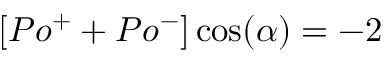Convert formula to latex. <formula><loc_0><loc_0><loc_500><loc_500>[ P o ^ { + } + P o ^ { - } ] \cos ( \alpha ) = - 2</formula> 